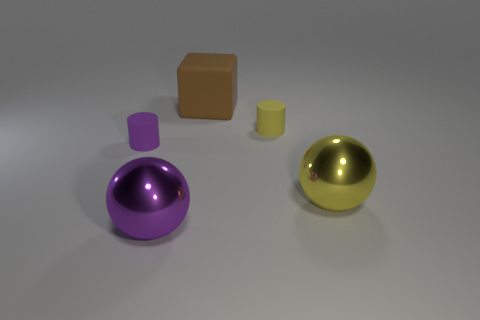There is a purple sphere that is the same size as the brown block; what material is it?
Provide a short and direct response. Metal. Is there a purple cylinder of the same size as the brown block?
Ensure brevity in your answer.  No. What is the color of the rubber cylinder on the left side of the cube?
Your response must be concise. Purple. Is there a rubber cube in front of the metallic thing left of the yellow sphere?
Provide a succinct answer. No. How many other objects are the same color as the matte cube?
Offer a very short reply. 0. Do the ball behind the large purple object and the cylinder to the left of the small yellow cylinder have the same size?
Your answer should be very brief. No. What is the size of the cylinder to the right of the small cylinder to the left of the large purple shiny sphere?
Provide a short and direct response. Small. There is a thing that is left of the large brown thing and on the right side of the small purple object; what is its material?
Keep it short and to the point. Metal. The rubber cube has what color?
Your answer should be compact. Brown. Is there any other thing that is made of the same material as the brown thing?
Ensure brevity in your answer.  Yes. 